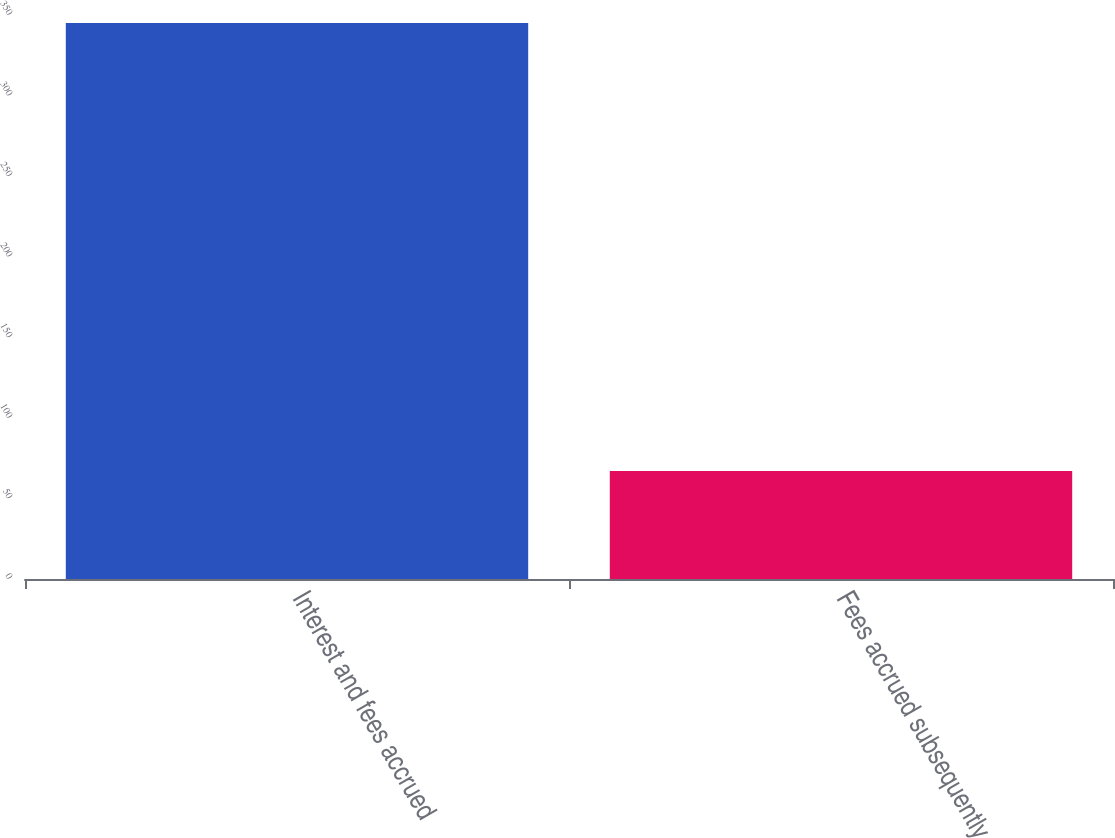Convert chart. <chart><loc_0><loc_0><loc_500><loc_500><bar_chart><fcel>Interest and fees accrued<fcel>Fees accrued subsequently<nl><fcel>345<fcel>67<nl></chart> 